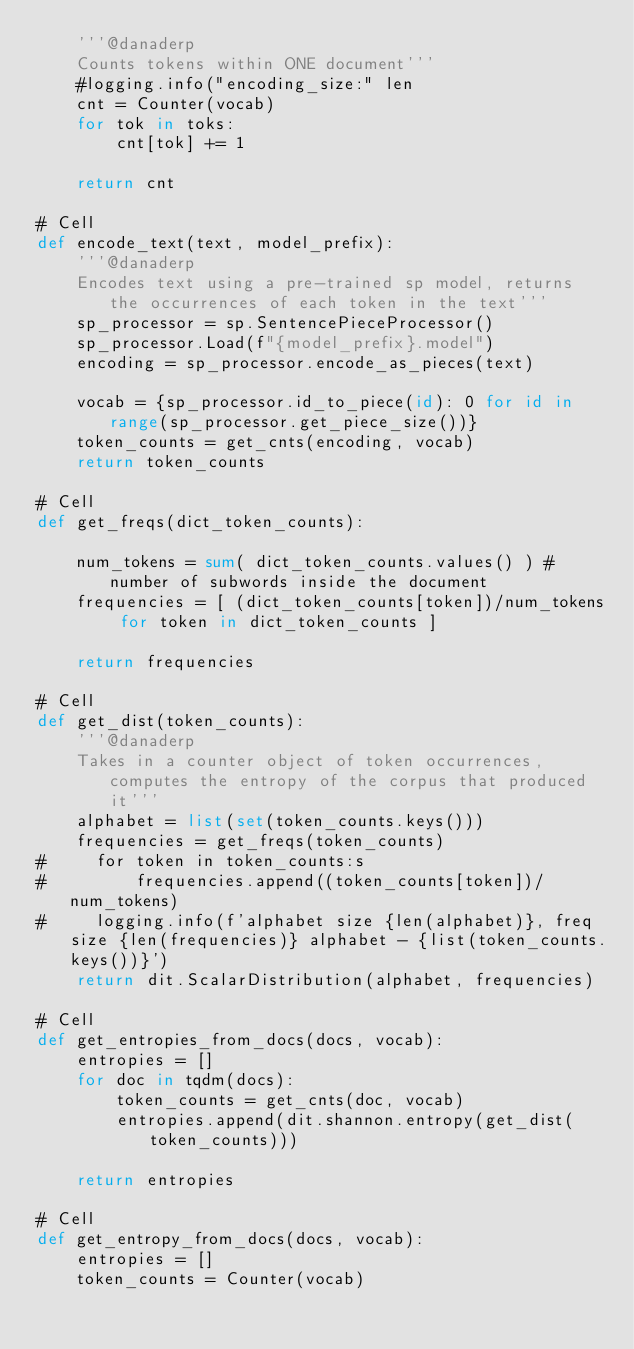Convert code to text. <code><loc_0><loc_0><loc_500><loc_500><_Python_>    '''@danaderp
    Counts tokens within ONE document'''
    #logging.info("encoding_size:" len
    cnt = Counter(vocab)
    for tok in toks:
        cnt[tok] += 1

    return cnt

# Cell
def encode_text(text, model_prefix):
    '''@danaderp
    Encodes text using a pre-trained sp model, returns the occurrences of each token in the text'''
    sp_processor = sp.SentencePieceProcessor()
    sp_processor.Load(f"{model_prefix}.model")
    encoding = sp_processor.encode_as_pieces(text)

    vocab = {sp_processor.id_to_piece(id): 0 for id in range(sp_processor.get_piece_size())}
    token_counts = get_cnts(encoding, vocab)
    return token_counts

# Cell
def get_freqs(dict_token_counts):

    num_tokens = sum( dict_token_counts.values() ) #number of subwords inside the document
    frequencies = [ (dict_token_counts[token])/num_tokens for token in dict_token_counts ]

    return frequencies

# Cell
def get_dist(token_counts):
    '''@danaderp
    Takes in a counter object of token occurrences, computes the entropy of the corpus that produced it'''
    alphabet = list(set(token_counts.keys()))
    frequencies = get_freqs(token_counts)
#     for token in token_counts:s
#         frequencies.append((token_counts[token])/num_tokens)
#     logging.info(f'alphabet size {len(alphabet)}, freq size {len(frequencies)} alphabet - {list(token_counts.keys())}')
    return dit.ScalarDistribution(alphabet, frequencies)

# Cell
def get_entropies_from_docs(docs, vocab):
    entropies = []
    for doc in tqdm(docs):
        token_counts = get_cnts(doc, vocab)
        entropies.append(dit.shannon.entropy(get_dist(token_counts)))

    return entropies

# Cell
def get_entropy_from_docs(docs, vocab):
    entropies = []
    token_counts = Counter(vocab)</code> 